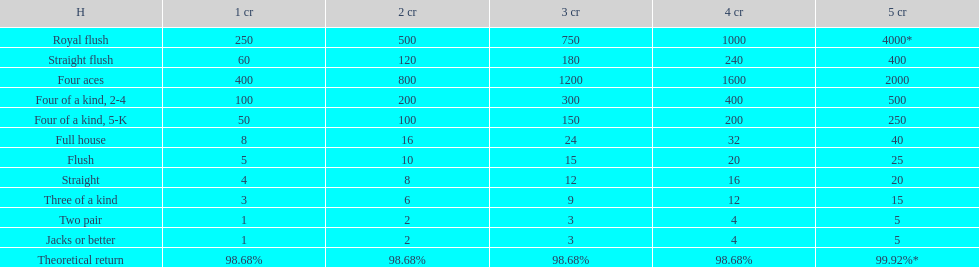Each four aces win is a multiple of what number? 400. 